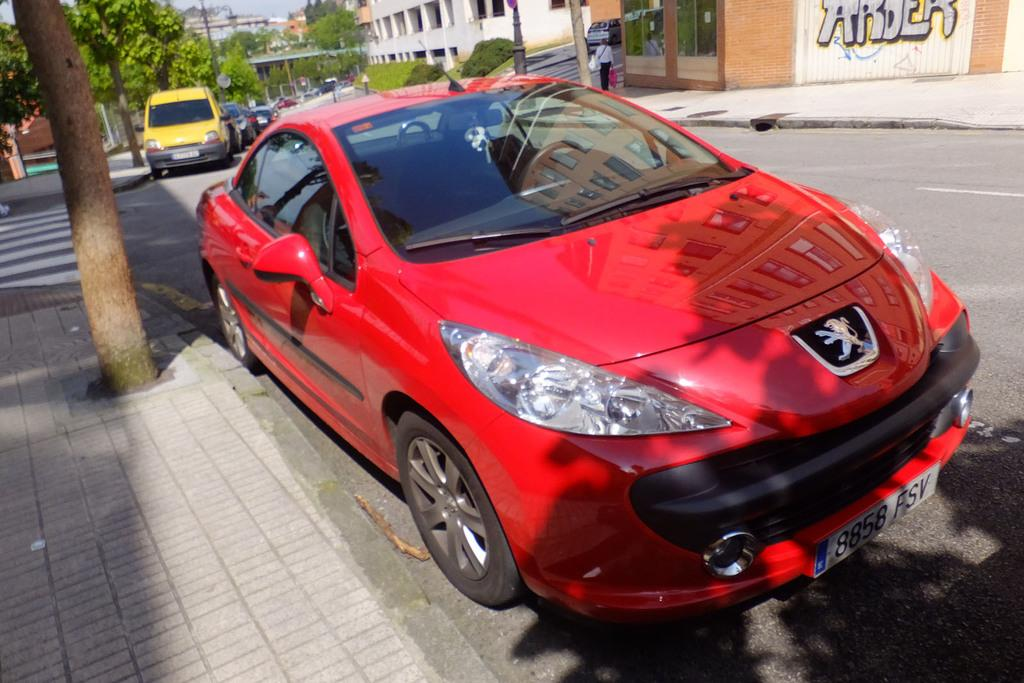What can be seen parked in the image? There are vehicles parked in the image. What natural element is present in the image? There is a tree trunk in the image, and there are trees towards the right side of the image. What is the person in the image carrying? There is a person carrying and holding a carry bag in the image. What type of structure is visible in the image? There is a building in the image. What type of pathway is present in the image? There is a road in the image. What type of scissors can be seen cutting the tree trunk in the image? There are no scissors present in the image, and the tree trunk is not being cut. What form of exercise is the person doing while holding the carry bag in the image? The person is not performing any exercise in the image; they are simply carrying a carry bag. 